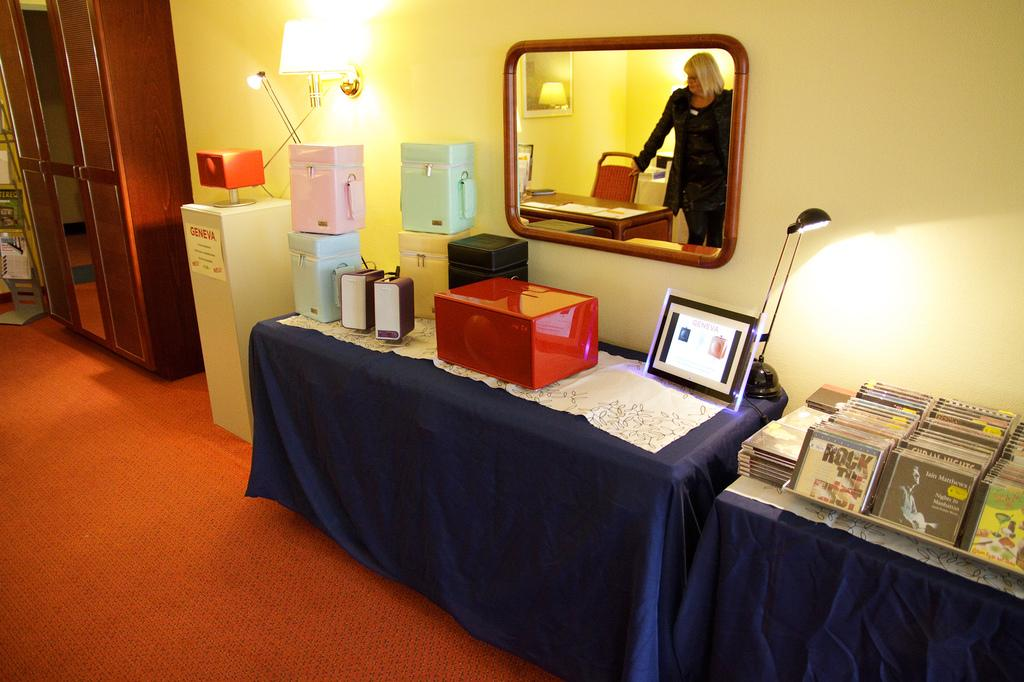Provide a one-sentence caption for the provided image. a cd with the word rock on it. 